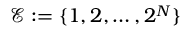Convert formula to latex. <formula><loc_0><loc_0><loc_500><loc_500>\mathcal { E } \colon = \{ 1 , 2 , \dots , 2 ^ { N } \}</formula> 